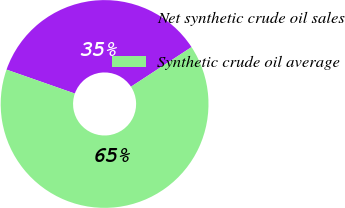<chart> <loc_0><loc_0><loc_500><loc_500><pie_chart><fcel>Net synthetic crude oil sales<fcel>Synthetic crude oil average<nl><fcel>35.42%<fcel>64.58%<nl></chart> 